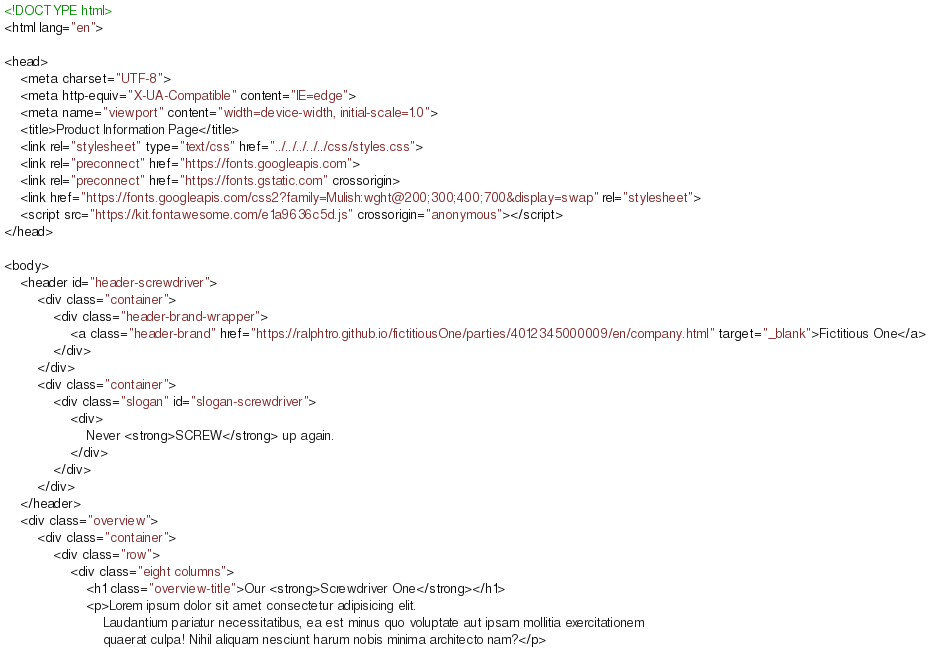<code> <loc_0><loc_0><loc_500><loc_500><_HTML_><!DOCTYPE html>
<html lang="en">

<head>
    <meta charset="UTF-8">
    <meta http-equiv="X-UA-Compatible" content="IE=edge">
    <meta name="viewport" content="width=device-width, initial-scale=1.0">
    <title>Product Information Page</title>
    <link rel="stylesheet" type="text/css" href="../../../../../css/styles.css">
    <link rel="preconnect" href="https://fonts.googleapis.com">
    <link rel="preconnect" href="https://fonts.gstatic.com" crossorigin>
    <link href="https://fonts.googleapis.com/css2?family=Mulish:wght@200;300;400;700&display=swap" rel="stylesheet">
    <script src="https://kit.fontawesome.com/e1a9636c5d.js" crossorigin="anonymous"></script>
</head>

<body>
    <header id="header-screwdriver">
        <div class="container">
            <div class="header-brand-wrapper">
                <a class="header-brand" href="https://ralphtro.github.io/fictitiousOne/parties/4012345000009/en/company.html" target="_blank">Fictitious One</a>
            </div>
        </div>
        <div class="container">
            <div class="slogan" id="slogan-screwdriver">
                <div>
                    Never <strong>SCREW</strong> up again.
                </div>
            </div>
        </div>
    </header>
    <div class="overview">
        <div class="container">
            <div class="row">
                <div class="eight columns">
                    <h1 class="overview-title">Our <strong>Screwdriver One</strong></h1>
                    <p>Lorem ipsum dolor sit amet consectetur adipisicing elit.
                        Laudantium pariatur necessitatibus, ea est minus quo voluptate aut ipsam mollitia exercitationem
                        quaerat culpa! Nihil aliquam nesciunt harum nobis minima architecto nam?</p></code> 